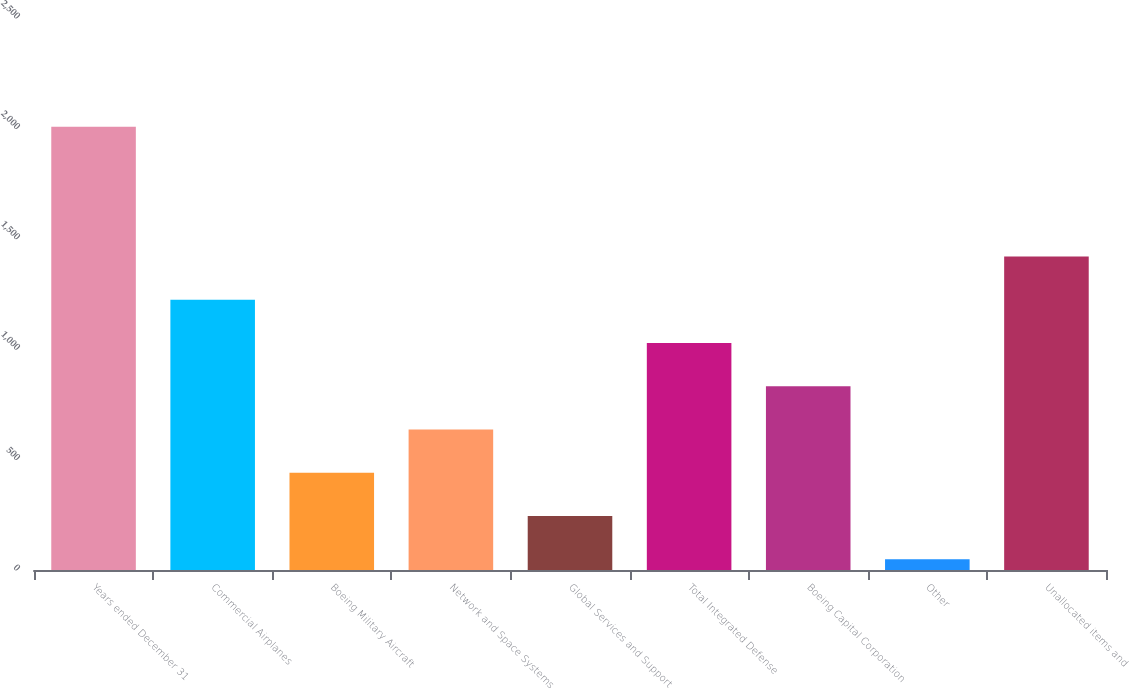Convert chart to OTSL. <chart><loc_0><loc_0><loc_500><loc_500><bar_chart><fcel>Years ended December 31<fcel>Commercial Airplanes<fcel>Boeing Military Aircraft<fcel>Network and Space Systems<fcel>Global Services and Support<fcel>Total Integrated Defense<fcel>Boeing Capital Corporation<fcel>Other<fcel>Unallocated items and<nl><fcel>2008<fcel>1224.4<fcel>440.8<fcel>636.7<fcel>244.9<fcel>1028.5<fcel>832.6<fcel>49<fcel>1420.3<nl></chart> 